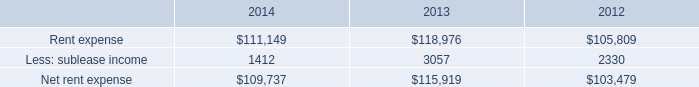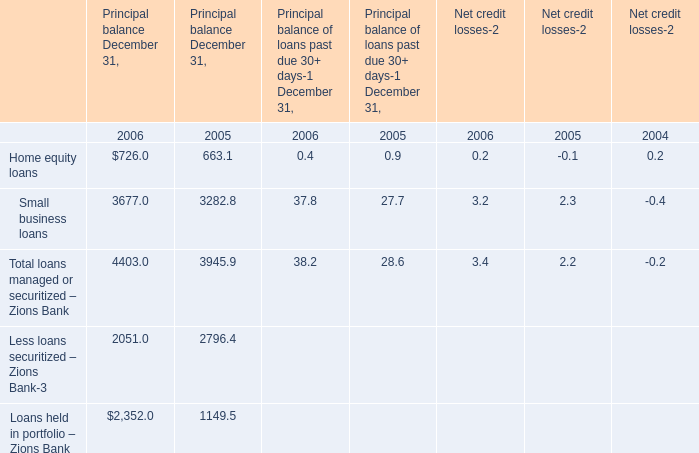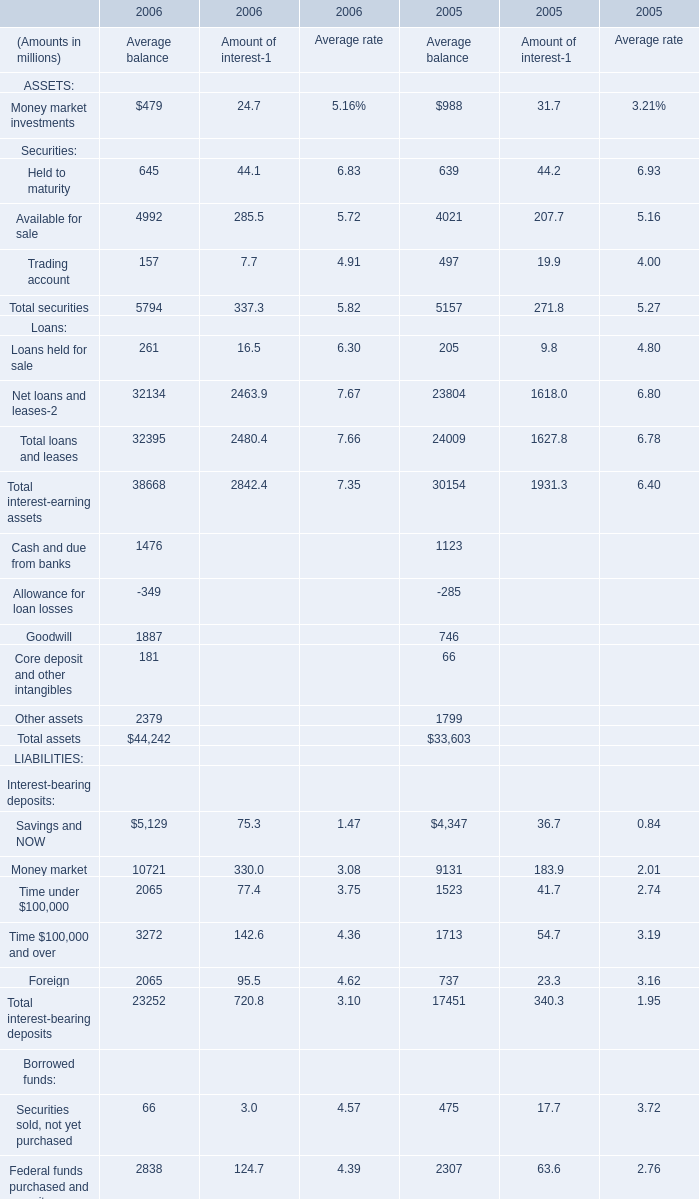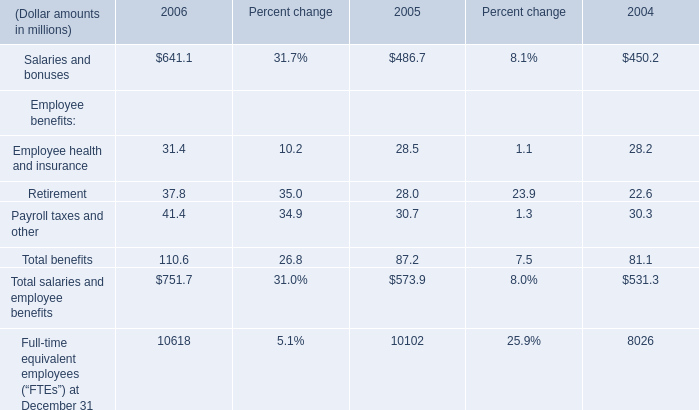Which year is Trading account for Amount of interest-1 the least? 
Answer: 2006. 